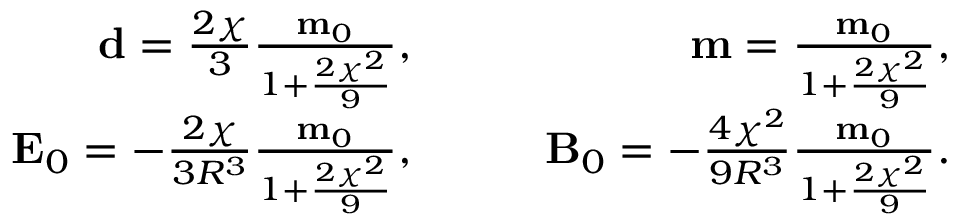Convert formula to latex. <formula><loc_0><loc_0><loc_500><loc_500>\begin{array} { r l r } { d = \frac { 2 \chi } { 3 } \frac { m _ { 0 } } { 1 + \frac { 2 \chi ^ { 2 } } { 9 } } , } & \quad } & { m = \frac { m _ { 0 } } { 1 + \frac { 2 \chi ^ { 2 } } { 9 } } , } \\ { E _ { 0 } = - \frac { 2 \chi } { 3 R ^ { 3 } } \frac { m _ { 0 } } { 1 + \frac { 2 \chi ^ { 2 } } { 9 } } , } & \quad } & { B _ { 0 } = - \frac { 4 \chi ^ { 2 } } { 9 R ^ { 3 } } \frac { m _ { 0 } } { 1 + \frac { 2 \chi ^ { 2 } } { 9 } } . } \end{array}</formula> 